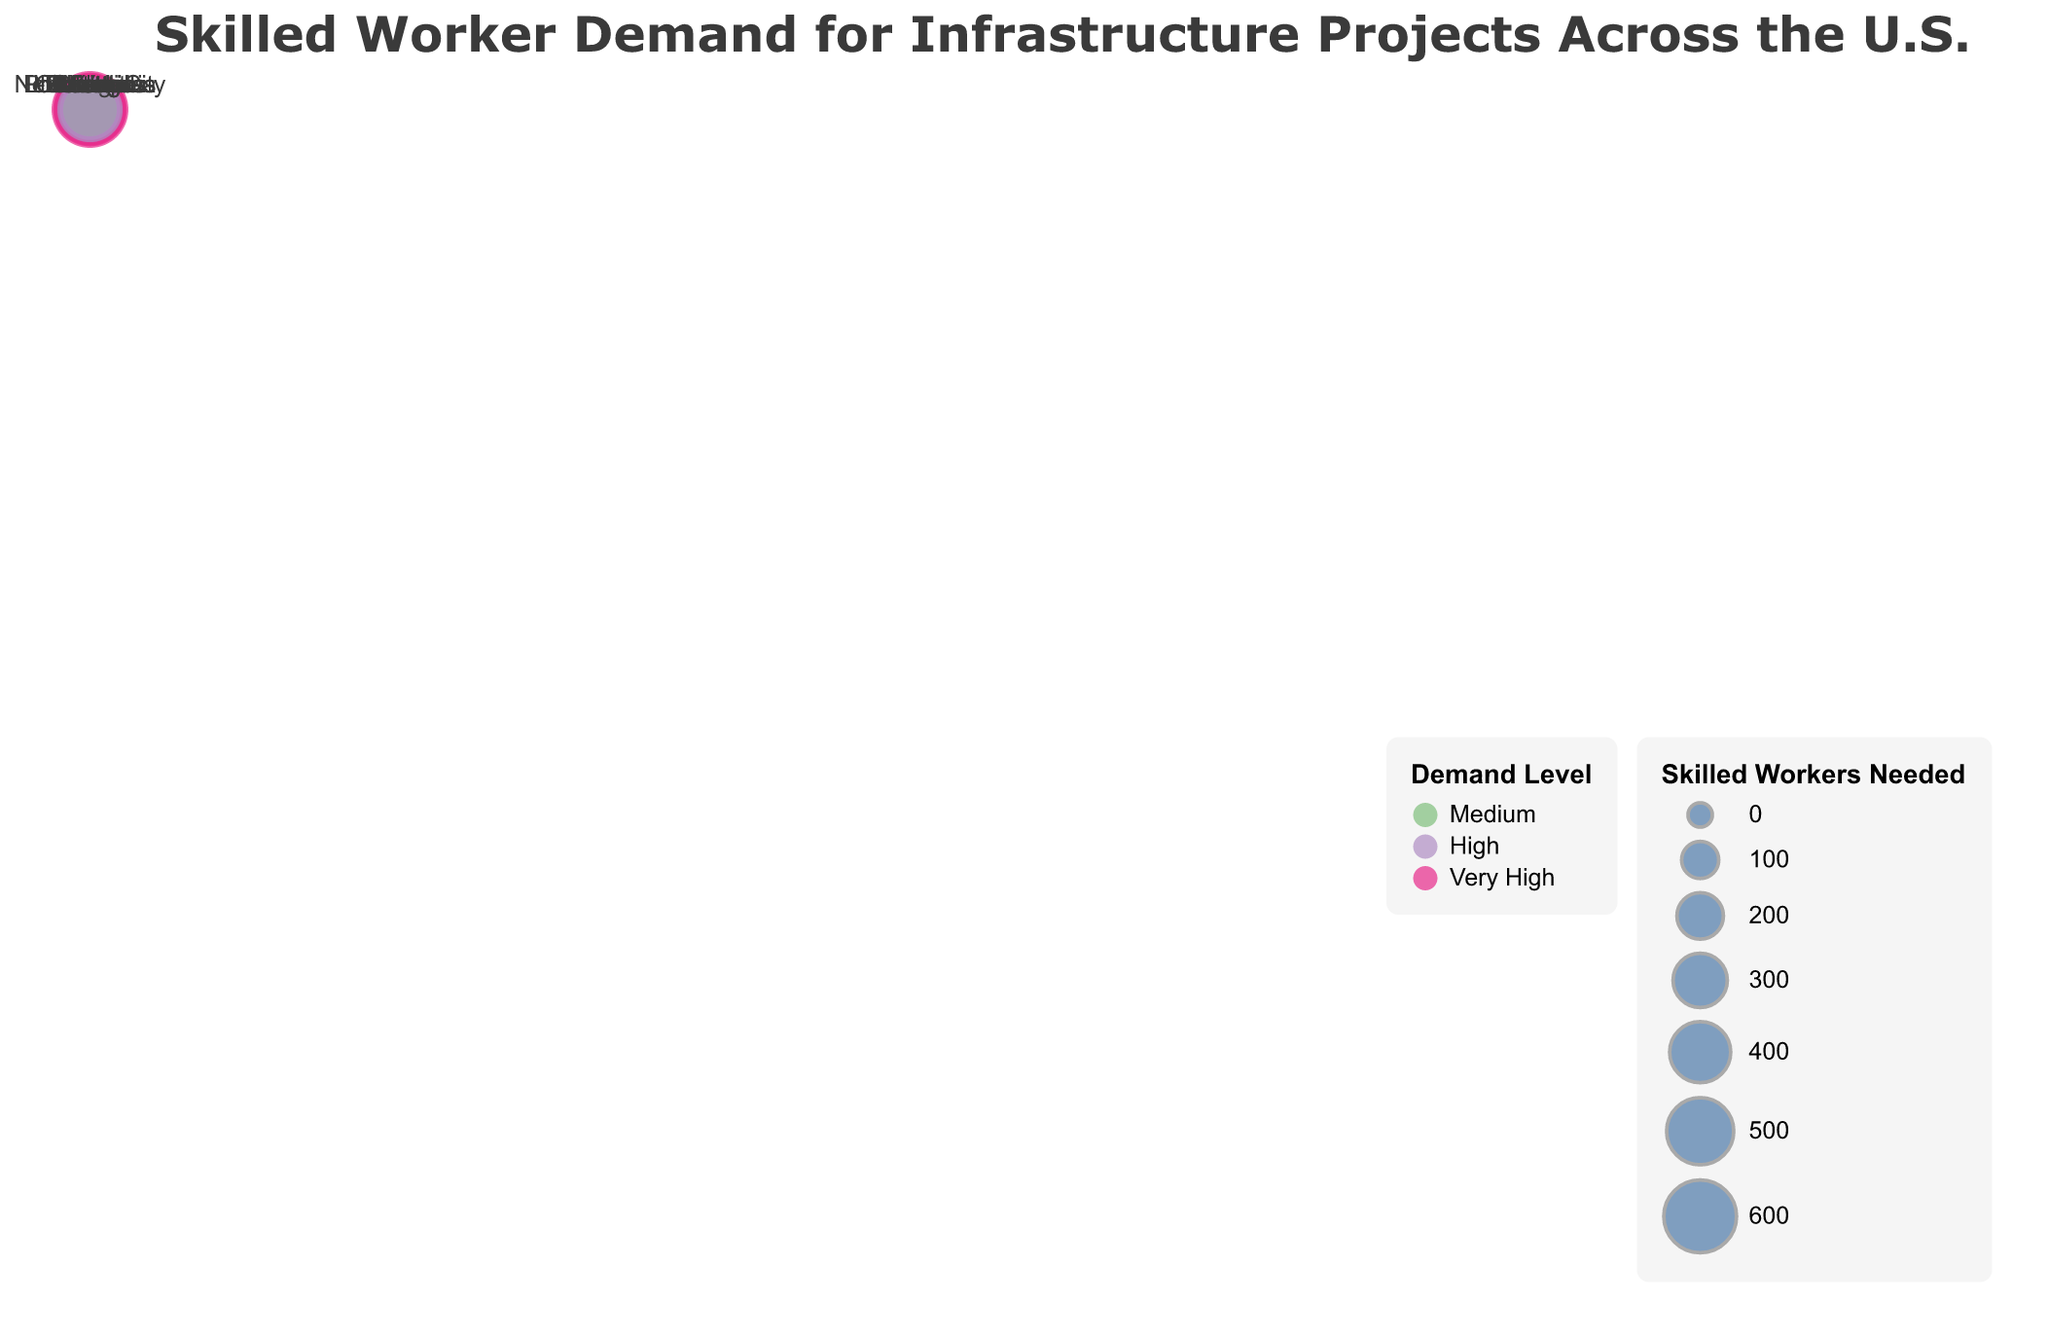Which city has the highest demand level for skilled workers? Look for the city where the demand level is marked as "Very High." According to the figure, Los Angeles falls into this category.
Answer: Los Angeles Which city needs the most skilled workers? Find the circle with the largest size, indicating the highest number of skilled workers needed. According to the figure, Los Angeles has the biggest circle.
Answer: Los Angeles How many cities have a demand level of "Medium"? Count the number of circles with a specific color representing the "Medium" demand level. According to the legend, "Medium" is represented in green. The cities are Miami, Denver, Phoenix, Philadelphia, and Portland.
Answer: 5 Which project type has a very high demand level in multiple cities? Identify the project types in cities with "Very High" demand level, represented by the pink color. The cities are Los Angeles, Seattle, and Boston, indicating three different project types without any repetitions.
Answer: None How many skilled workers are needed in total for cities with "High" demand levels? Sum the number of skilled workers needed for cities with "High" demand, including Houston, New York City, Chicago, Atlanta, Detroit, Las Vegas, and Columbus. The total is 450 (Houston) + 520 (New York City) + 410 (Chicago) + 480 (Atlanta) + 430 (Detroit) + 470 (Las Vegas) + 400 (Columbus) = 3160.
Answer: 3160 